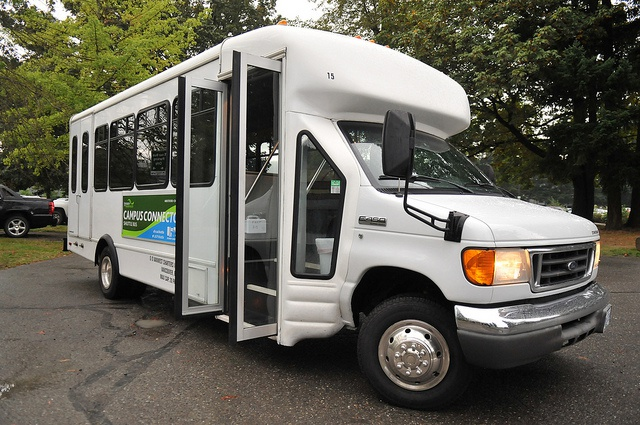Describe the objects in this image and their specific colors. I can see bus in gray, black, lightgray, and darkgray tones, car in gray, black, darkgray, and maroon tones, and truck in gray, black, lightgray, and darkgray tones in this image. 